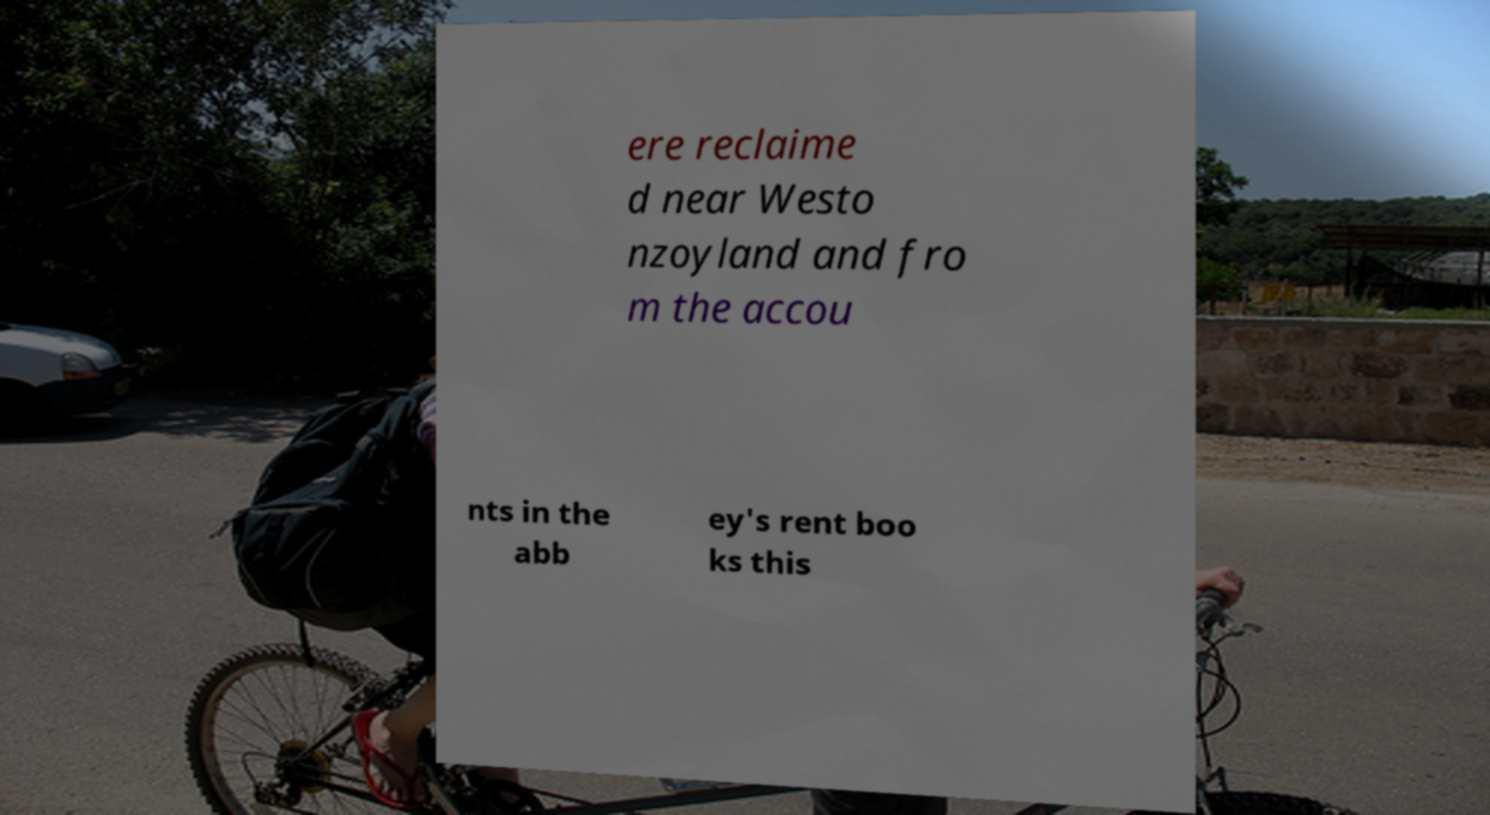What messages or text are displayed in this image? I need them in a readable, typed format. ere reclaime d near Westo nzoyland and fro m the accou nts in the abb ey's rent boo ks this 